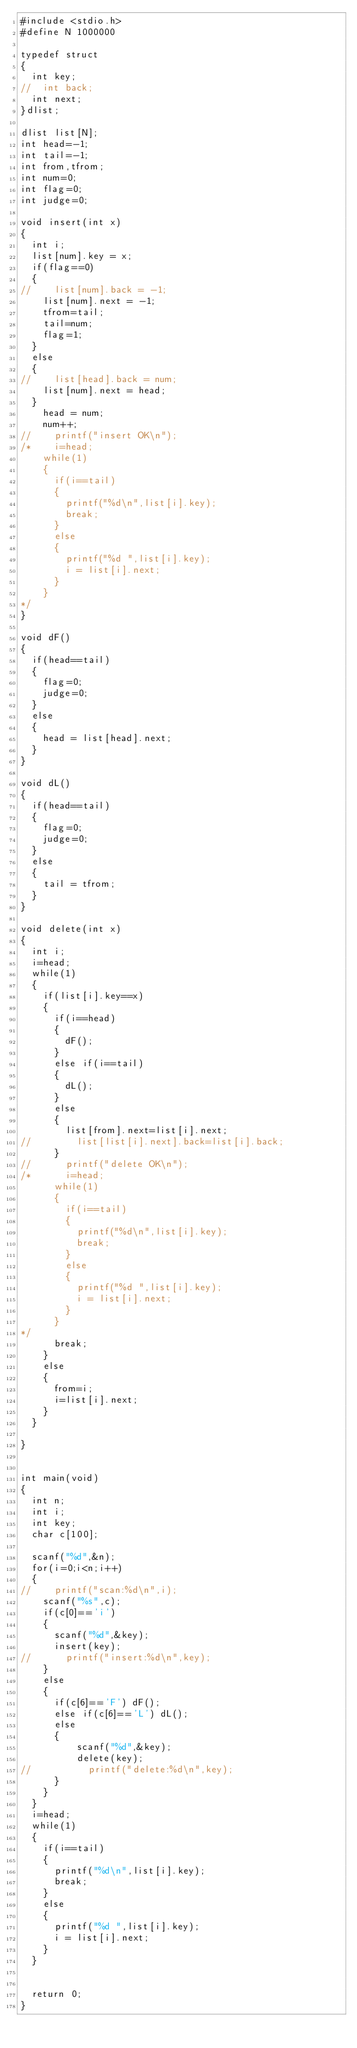Convert code to text. <code><loc_0><loc_0><loc_500><loc_500><_C_>#include <stdio.h>
#define N 1000000

typedef struct
{
  int key;
//  int back;
  int next;
}dlist;

dlist list[N];
int head=-1;
int tail=-1;
int from,tfrom;
int num=0;
int flag=0;
int judge=0;

void insert(int x)
{
  int i;
  list[num].key = x;
  if(flag==0)
  {
//    list[num].back = -1;
    list[num].next = -1;
    tfrom=tail;
    tail=num;
    flag=1;
  }
  else
  {
//    list[head].back = num;
    list[num].next = head;
  }
    head = num;
    num++;
//    printf("insert OK\n");
/*    i=head;
    while(1)
    {
      if(i==tail)
      {
        printf("%d\n",list[i].key);
        break;
      }
      else
      {
        printf("%d ",list[i].key);
        i = list[i].next;
      }
    }
*/
}

void dF()
{
  if(head==tail)
  {
    flag=0;
    judge=0;
  }
  else
  {
    head = list[head].next;
  }
}

void dL()
{
  if(head==tail)
  {
    flag=0;
    judge=0;
  }
  else
  {
    tail = tfrom;
  }
}

void delete(int x)
{
  int i;
  i=head;
  while(1)
  {
    if(list[i].key==x)
    {
      if(i==head)
      {
        dF();
      }
      else if(i==tail)
      {
        dL();
      }
      else
      {
        list[from].next=list[i].next;
//        list[list[i].next].back=list[i].back;
      }
//      printf("delete OK\n");
/*      i=head;
      while(1)
      {
        if(i==tail)
        {
          printf("%d\n",list[i].key);
          break;
        }
        else
        {
          printf("%d ",list[i].key);
          i = list[i].next;
        }
      }
*/
      break;
    }
    else
    {
      from=i;
      i=list[i].next;
    }
  }

}


int main(void)
{
  int n;
  int i;
  int key;
  char c[100];

  scanf("%d",&n);
  for(i=0;i<n;i++)
  {
//    printf("scan:%d\n",i);
    scanf("%s",c);
    if(c[0]=='i')
    {
      scanf("%d",&key);
      insert(key);
//      printf("insert:%d\n",key);
    }
    else
    {
      if(c[6]=='F') dF();
      else if(c[6]=='L') dL();
      else
      {
          scanf("%d",&key);
          delete(key);
//          printf("delete:%d\n",key);
      }
    }
  }
  i=head;
  while(1)
  {
    if(i==tail)
    {
      printf("%d\n",list[i].key);
      break;
    }
    else
    {
      printf("%d ",list[i].key);
      i = list[i].next;
    }
  }


  return 0;
}</code> 